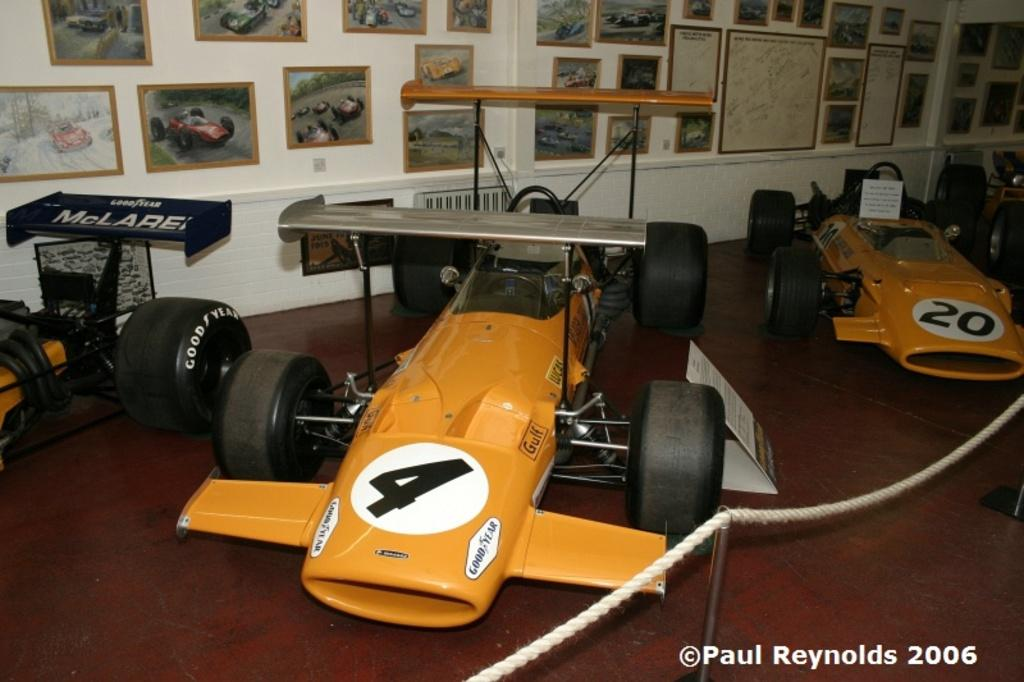What are the main subjects in the image? There are three racing cars in the image. What else can be seen in the image besides the racing cars? There is a rope and photo frames of cars in the image. What is the background of the image? There is a white wall behind the cars in the image. What type of suit is the driver wearing in the image? There are no drivers visible in the image, and therefore no suits can be observed. What type of harmony is being depicted in the image? The image does not depict any musical or emotional harmony; it features racing cars and related items. 